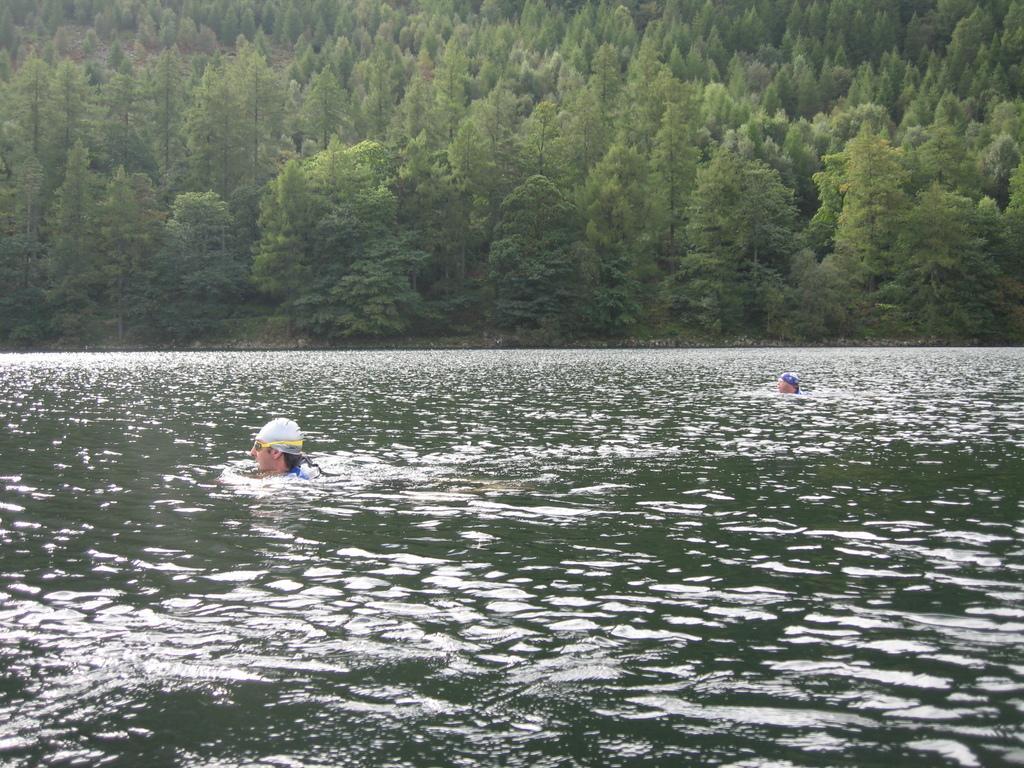How would you summarize this image in a sentence or two? In this picture I can see two people in the water. I can see trees in the background. 